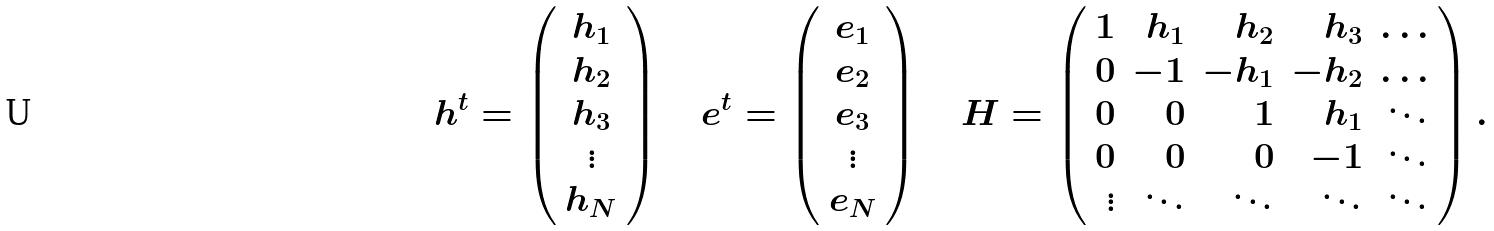Convert formula to latex. <formula><loc_0><loc_0><loc_500><loc_500>h ^ { t } = \left ( \begin{array} { c } h _ { 1 } \\ h _ { 2 } \\ h _ { 3 } \\ \vdots \\ h _ { N } \\ \end{array} \right ) \quad e ^ { t } = \left ( \begin{array} { c } e _ { 1 } \\ e _ { 2 } \\ e _ { 3 } \\ \vdots \\ e _ { N } \\ \end{array} \right ) \quad H = \left ( \begin{array} { r r r r r } 1 & h _ { 1 } & h _ { 2 } & h _ { 3 } & \dots \\ 0 & - 1 & - h _ { 1 } & - h _ { 2 } & \dots \\ 0 & 0 & 1 & h _ { 1 } & \ddots \\ 0 & 0 & 0 & - 1 & \ddots \\ \vdots & \ddots & \ddots & \ddots & \ddots \\ \end{array} \right ) .</formula> 